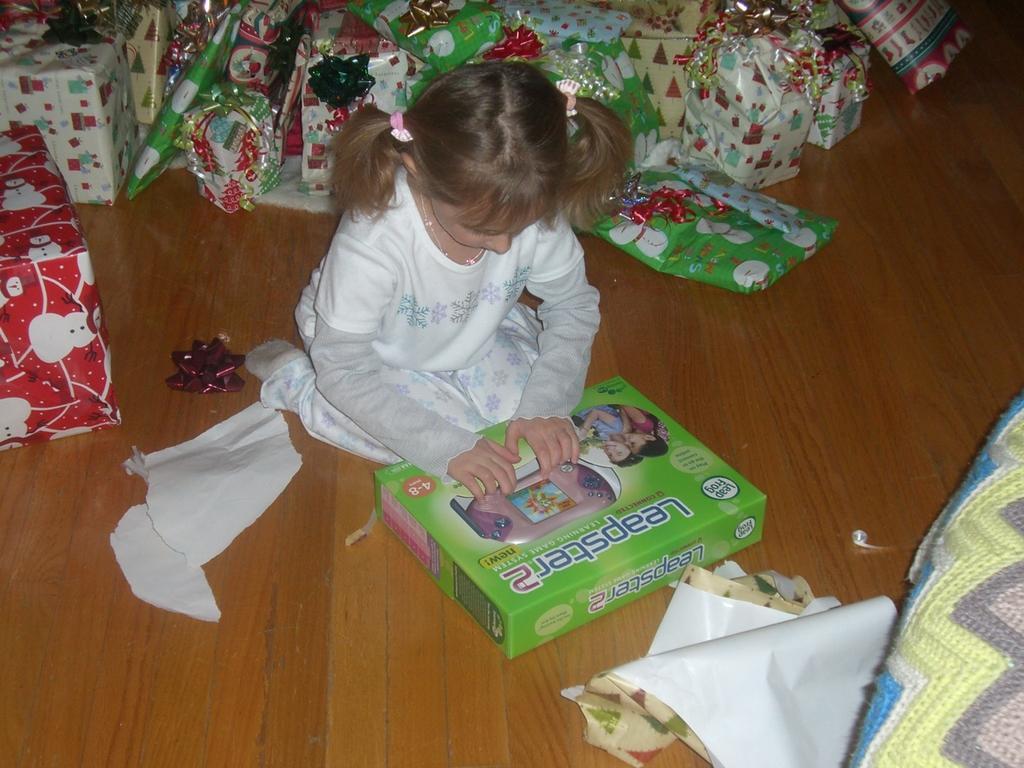In one or two sentences, can you explain what this image depicts? This picture shows a girl seated on the floor and she is holding a box which is on the floor and we see few gifts and boxes and papers on the floor. 